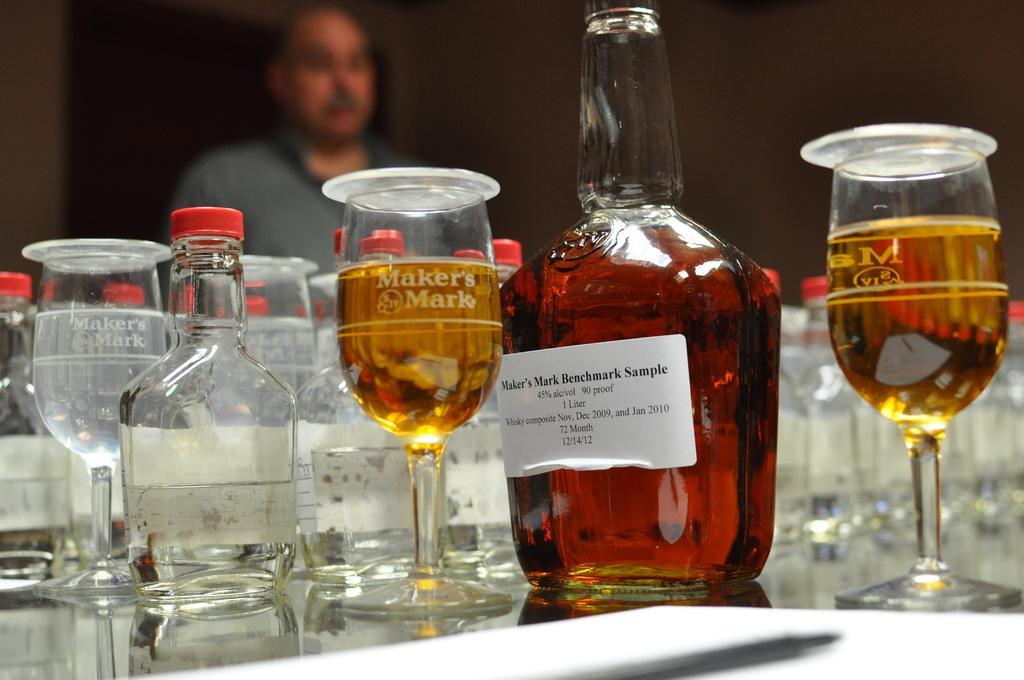Describe this image in one or two sentences. In the foreground of the picture there is a table, on the table there is a whiskey bottle and there are many glasses. In the background the person is standing. 